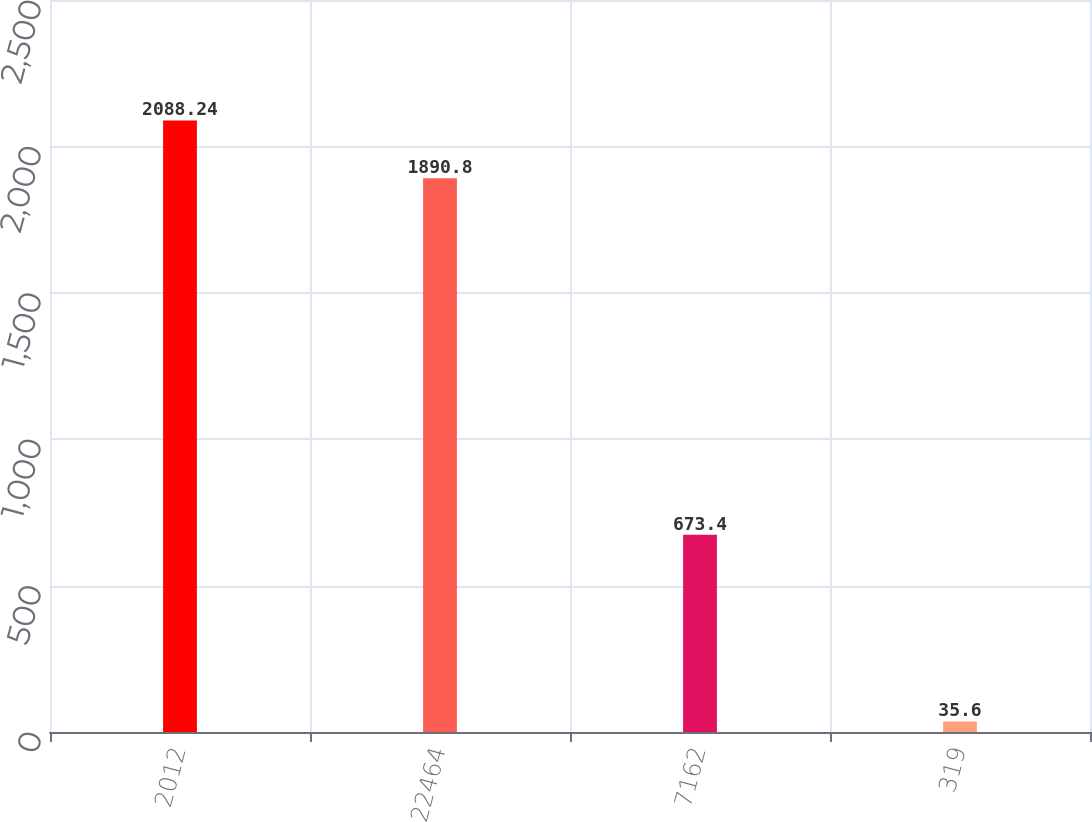Convert chart to OTSL. <chart><loc_0><loc_0><loc_500><loc_500><bar_chart><fcel>2012<fcel>22464<fcel>7162<fcel>319<nl><fcel>2088.24<fcel>1890.8<fcel>673.4<fcel>35.6<nl></chart> 